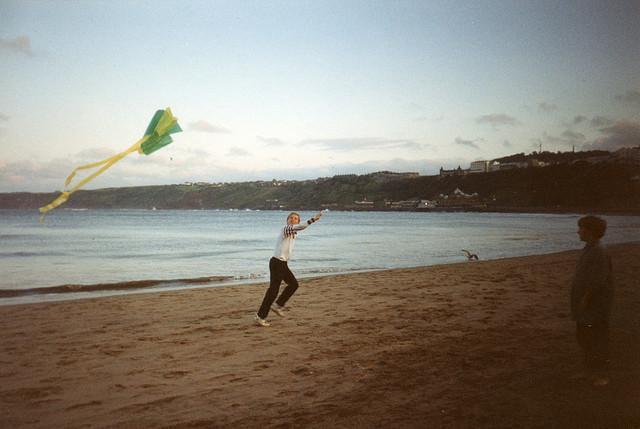Where is the kite in relation to the boy?
Make your selection from the four choices given to correctly answer the question.
Options: Under, in front, behind, invisible. Behind. 